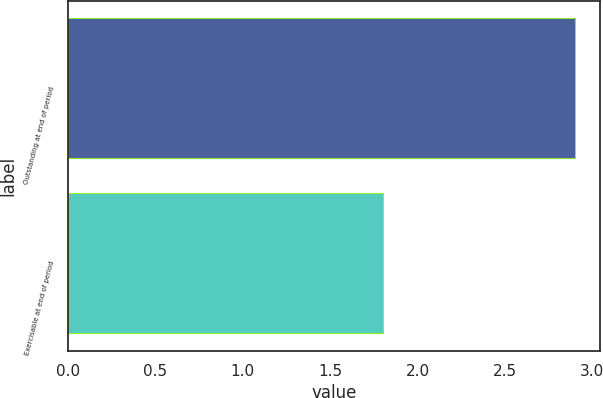Convert chart to OTSL. <chart><loc_0><loc_0><loc_500><loc_500><bar_chart><fcel>Outstanding at end of period<fcel>Exercisable at end of period<nl><fcel>2.9<fcel>1.8<nl></chart> 